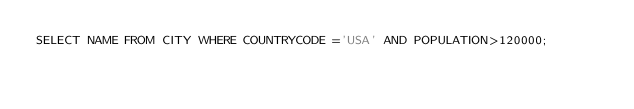Convert code to text. <code><loc_0><loc_0><loc_500><loc_500><_SQL_>SELECT NAME FROM CITY WHERE COUNTRYCODE ='USA' AND POPULATION>120000;
</code> 